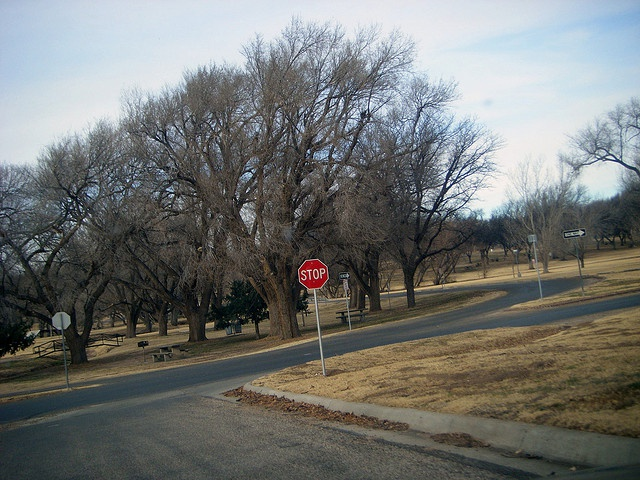Describe the objects in this image and their specific colors. I can see a stop sign in lightblue, brown, maroon, and darkgray tones in this image. 